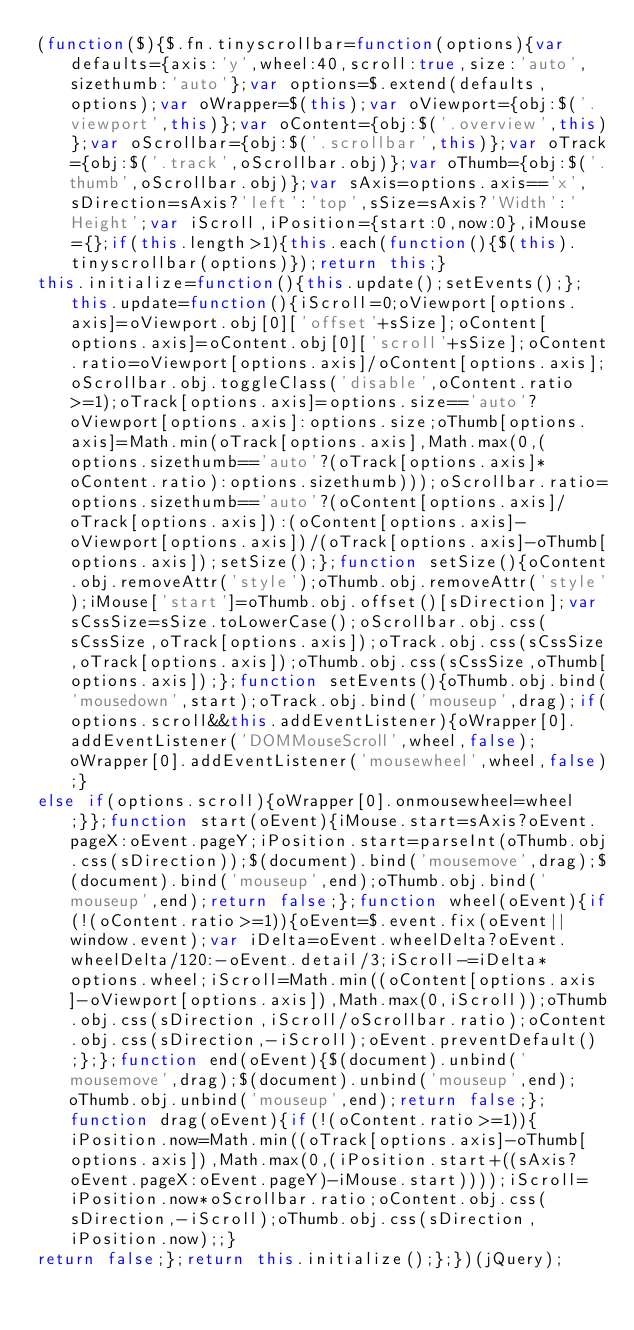<code> <loc_0><loc_0><loc_500><loc_500><_JavaScript_>(function($){$.fn.tinyscrollbar=function(options){var defaults={axis:'y',wheel:40,scroll:true,size:'auto',sizethumb:'auto'};var options=$.extend(defaults,options);var oWrapper=$(this);var oViewport={obj:$('.viewport',this)};var oContent={obj:$('.overview',this)};var oScrollbar={obj:$('.scrollbar',this)};var oTrack={obj:$('.track',oScrollbar.obj)};var oThumb={obj:$('.thumb',oScrollbar.obj)};var sAxis=options.axis=='x',sDirection=sAxis?'left':'top',sSize=sAxis?'Width':'Height';var iScroll,iPosition={start:0,now:0},iMouse={};if(this.length>1){this.each(function(){$(this).tinyscrollbar(options)});return this;}
this.initialize=function(){this.update();setEvents();};this.update=function(){iScroll=0;oViewport[options.axis]=oViewport.obj[0]['offset'+sSize];oContent[options.axis]=oContent.obj[0]['scroll'+sSize];oContent.ratio=oViewport[options.axis]/oContent[options.axis];oScrollbar.obj.toggleClass('disable',oContent.ratio>=1);oTrack[options.axis]=options.size=='auto'?oViewport[options.axis]:options.size;oThumb[options.axis]=Math.min(oTrack[options.axis],Math.max(0,(options.sizethumb=='auto'?(oTrack[options.axis]*oContent.ratio):options.sizethumb)));oScrollbar.ratio=options.sizethumb=='auto'?(oContent[options.axis]/oTrack[options.axis]):(oContent[options.axis]-oViewport[options.axis])/(oTrack[options.axis]-oThumb[options.axis]);setSize();};function setSize(){oContent.obj.removeAttr('style');oThumb.obj.removeAttr('style');iMouse['start']=oThumb.obj.offset()[sDirection];var sCssSize=sSize.toLowerCase();oScrollbar.obj.css(sCssSize,oTrack[options.axis]);oTrack.obj.css(sCssSize,oTrack[options.axis]);oThumb.obj.css(sCssSize,oThumb[options.axis]);};function setEvents(){oThumb.obj.bind('mousedown',start);oTrack.obj.bind('mouseup',drag);if(options.scroll&&this.addEventListener){oWrapper[0].addEventListener('DOMMouseScroll',wheel,false);oWrapper[0].addEventListener('mousewheel',wheel,false);}
else if(options.scroll){oWrapper[0].onmousewheel=wheel;}};function start(oEvent){iMouse.start=sAxis?oEvent.pageX:oEvent.pageY;iPosition.start=parseInt(oThumb.obj.css(sDirection));$(document).bind('mousemove',drag);$(document).bind('mouseup',end);oThumb.obj.bind('mouseup',end);return false;};function wheel(oEvent){if(!(oContent.ratio>=1)){oEvent=$.event.fix(oEvent||window.event);var iDelta=oEvent.wheelDelta?oEvent.wheelDelta/120:-oEvent.detail/3;iScroll-=iDelta*options.wheel;iScroll=Math.min((oContent[options.axis]-oViewport[options.axis]),Math.max(0,iScroll));oThumb.obj.css(sDirection,iScroll/oScrollbar.ratio);oContent.obj.css(sDirection,-iScroll);oEvent.preventDefault();};};function end(oEvent){$(document).unbind('mousemove',drag);$(document).unbind('mouseup',end);oThumb.obj.unbind('mouseup',end);return false;};function drag(oEvent){if(!(oContent.ratio>=1)){iPosition.now=Math.min((oTrack[options.axis]-oThumb[options.axis]),Math.max(0,(iPosition.start+((sAxis?oEvent.pageX:oEvent.pageY)-iMouse.start))));iScroll=iPosition.now*oScrollbar.ratio;oContent.obj.css(sDirection,-iScroll);oThumb.obj.css(sDirection,iPosition.now);;}
return false;};return this.initialize();};})(jQuery);</code> 